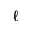Convert formula to latex. <formula><loc_0><loc_0><loc_500><loc_500>\ell</formula> 